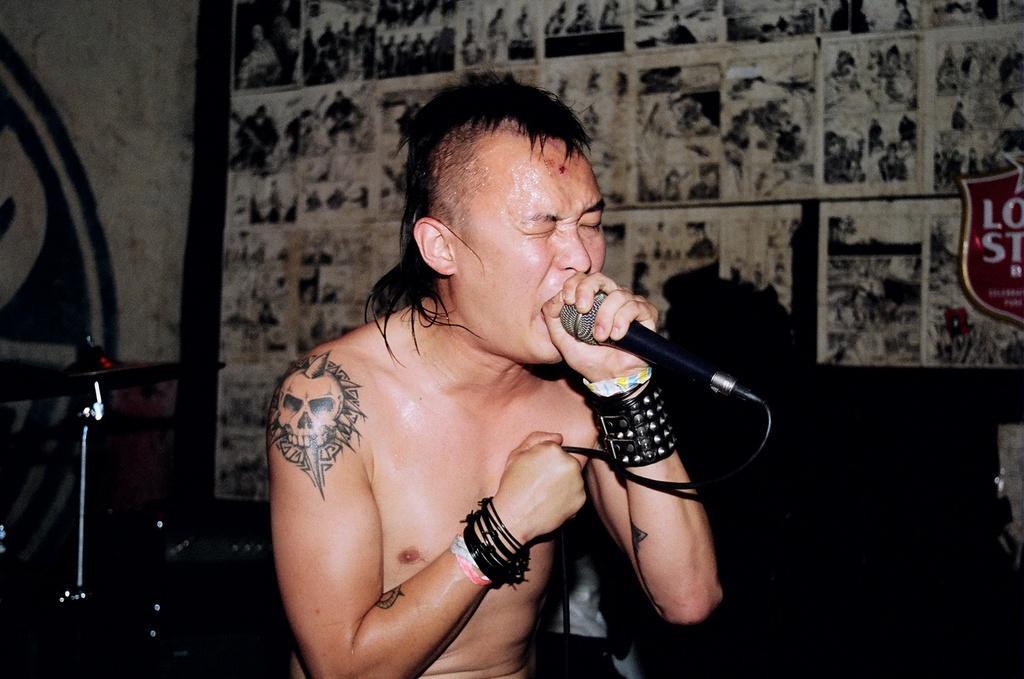How would you summarize this image in a sentence or two? In the image we can see a man wearing a bracelet and he is holding a microphone in one hand and on the other hand there is a cable wire. Here we can see the text, musical instruments and the background is slightly blurred. 